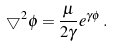Convert formula to latex. <formula><loc_0><loc_0><loc_500><loc_500>\bigtriangledown ^ { 2 } \phi = \frac { \mu } { 2 \gamma } e ^ { \gamma \phi } \, .</formula> 